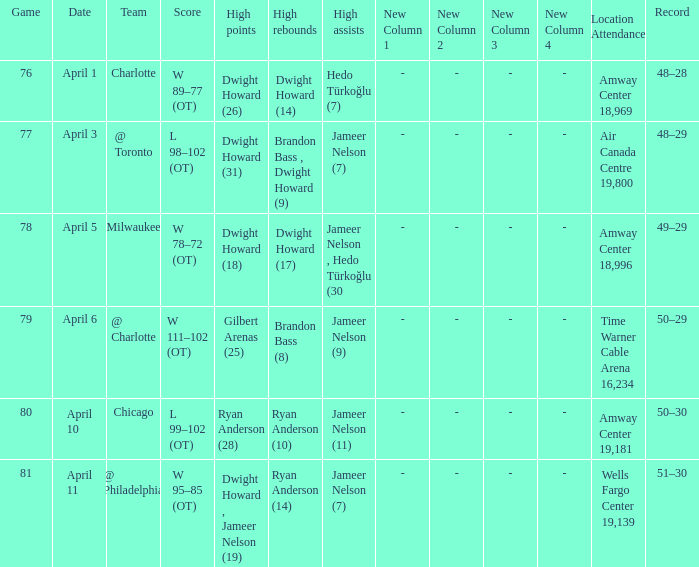Where was the game and what was the attendance on April 3?  Air Canada Centre 19,800. 